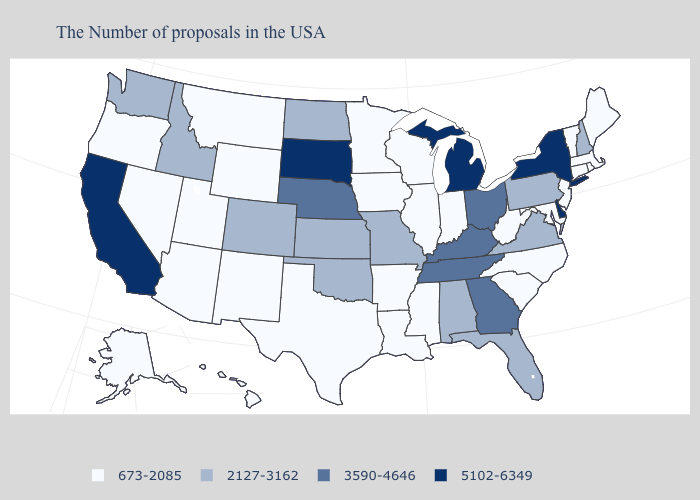What is the value of Nebraska?
Answer briefly. 3590-4646. What is the value of Michigan?
Quick response, please. 5102-6349. Name the states that have a value in the range 2127-3162?
Answer briefly. New Hampshire, Pennsylvania, Virginia, Florida, Alabama, Missouri, Kansas, Oklahoma, North Dakota, Colorado, Idaho, Washington. Which states have the lowest value in the USA?
Give a very brief answer. Maine, Massachusetts, Rhode Island, Vermont, Connecticut, New Jersey, Maryland, North Carolina, South Carolina, West Virginia, Indiana, Wisconsin, Illinois, Mississippi, Louisiana, Arkansas, Minnesota, Iowa, Texas, Wyoming, New Mexico, Utah, Montana, Arizona, Nevada, Oregon, Alaska, Hawaii. Name the states that have a value in the range 673-2085?
Be succinct. Maine, Massachusetts, Rhode Island, Vermont, Connecticut, New Jersey, Maryland, North Carolina, South Carolina, West Virginia, Indiana, Wisconsin, Illinois, Mississippi, Louisiana, Arkansas, Minnesota, Iowa, Texas, Wyoming, New Mexico, Utah, Montana, Arizona, Nevada, Oregon, Alaska, Hawaii. What is the value of Ohio?
Write a very short answer. 3590-4646. Does South Carolina have the same value as Oklahoma?
Answer briefly. No. What is the highest value in the USA?
Concise answer only. 5102-6349. What is the value of Alaska?
Keep it brief. 673-2085. Name the states that have a value in the range 3590-4646?
Keep it brief. Ohio, Georgia, Kentucky, Tennessee, Nebraska. Which states have the lowest value in the South?
Short answer required. Maryland, North Carolina, South Carolina, West Virginia, Mississippi, Louisiana, Arkansas, Texas. What is the value of Wyoming?
Keep it brief. 673-2085. Does Connecticut have the lowest value in the Northeast?
Write a very short answer. Yes. What is the highest value in the West ?
Give a very brief answer. 5102-6349. Which states hav the highest value in the MidWest?
Keep it brief. Michigan, South Dakota. 